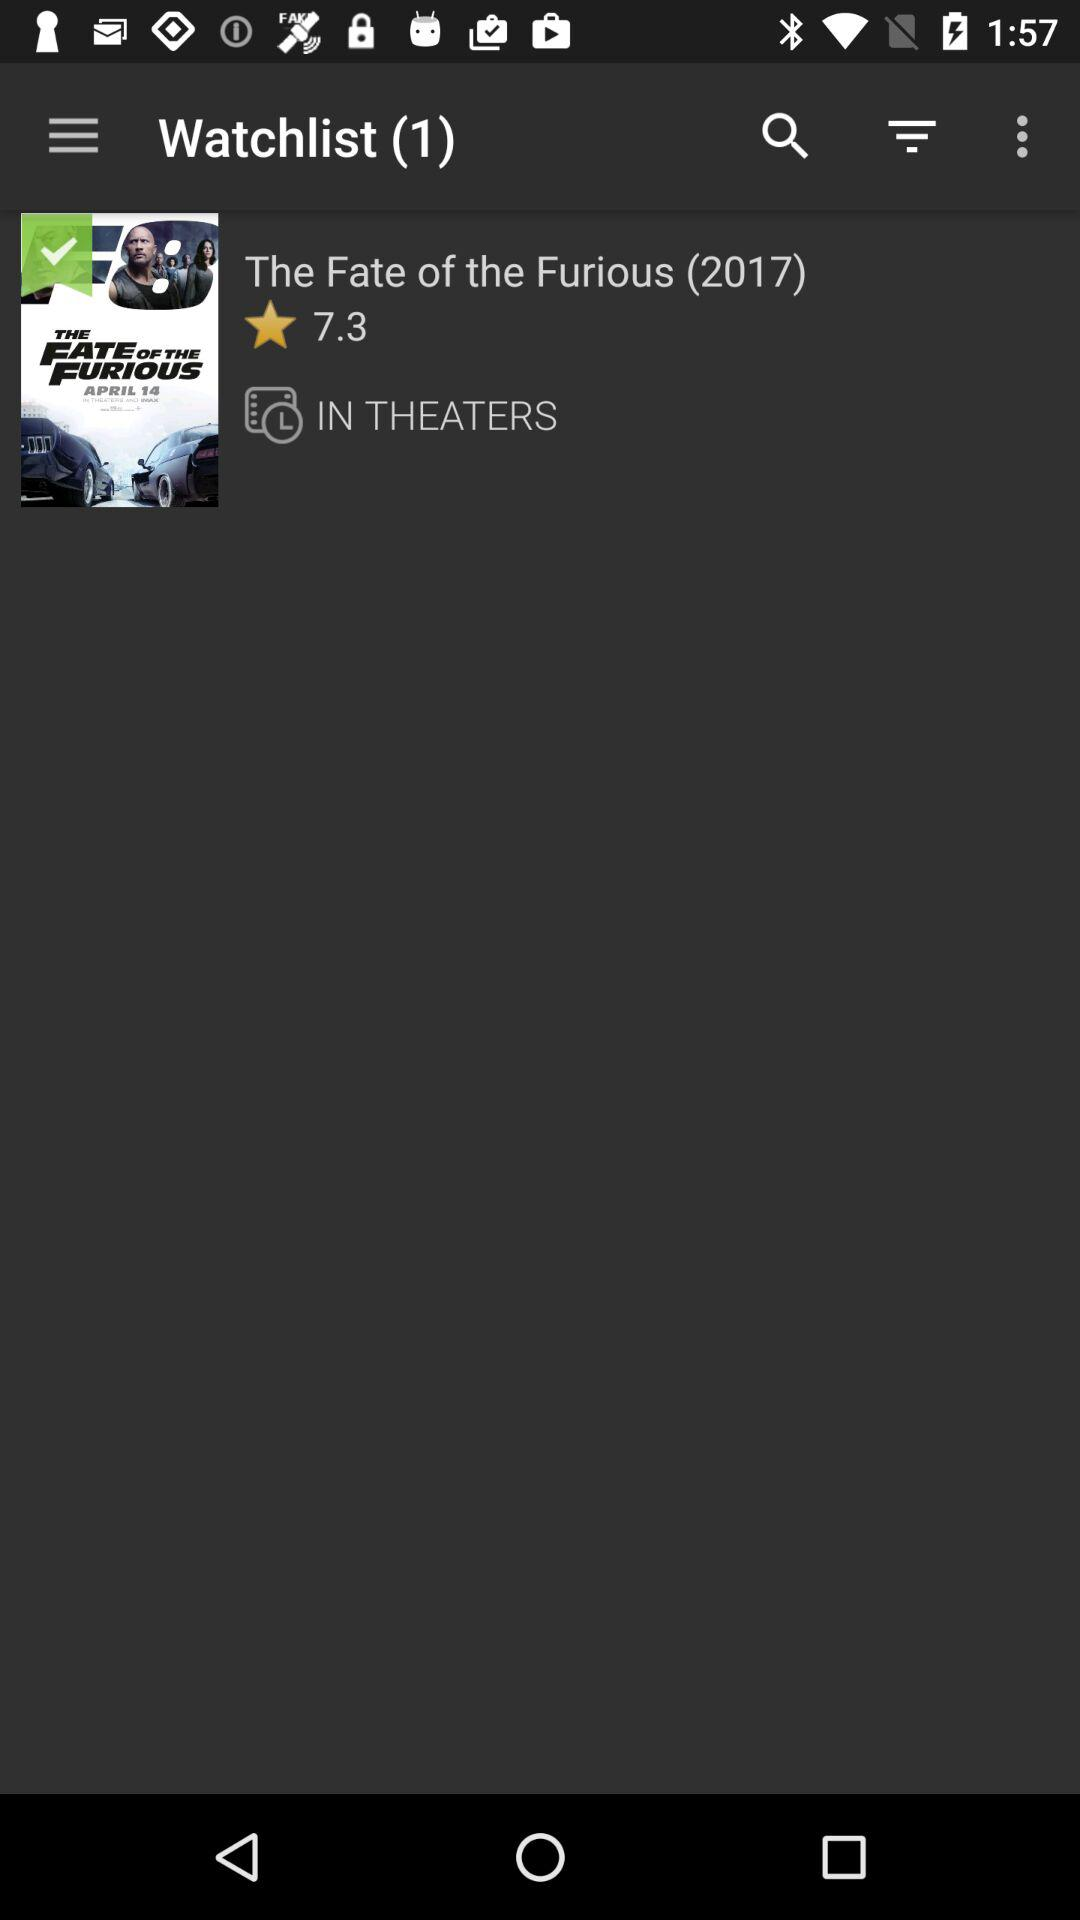What is the rating of The Fate of the Furious (2017)? The rating is 7.3. 